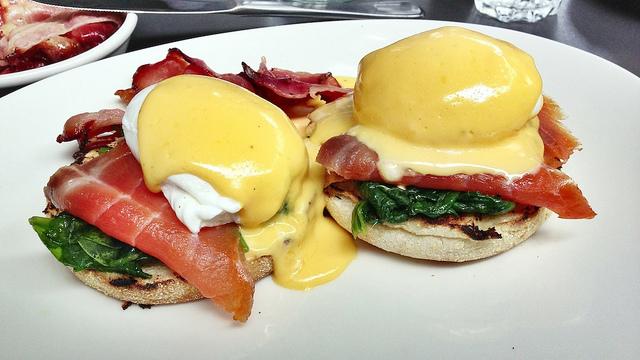What color are the plates?
Give a very brief answer. White. Is that gravy on top of the food?
Write a very short answer. No. Is this vegetarian food?
Be succinct. No. 